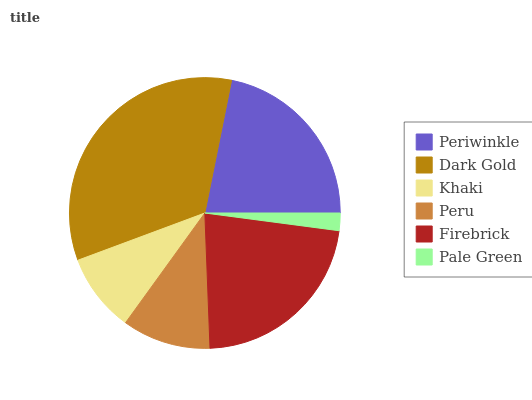Is Pale Green the minimum?
Answer yes or no. Yes. Is Dark Gold the maximum?
Answer yes or no. Yes. Is Khaki the minimum?
Answer yes or no. No. Is Khaki the maximum?
Answer yes or no. No. Is Dark Gold greater than Khaki?
Answer yes or no. Yes. Is Khaki less than Dark Gold?
Answer yes or no. Yes. Is Khaki greater than Dark Gold?
Answer yes or no. No. Is Dark Gold less than Khaki?
Answer yes or no. No. Is Periwinkle the high median?
Answer yes or no. Yes. Is Peru the low median?
Answer yes or no. Yes. Is Peru the high median?
Answer yes or no. No. Is Pale Green the low median?
Answer yes or no. No. 